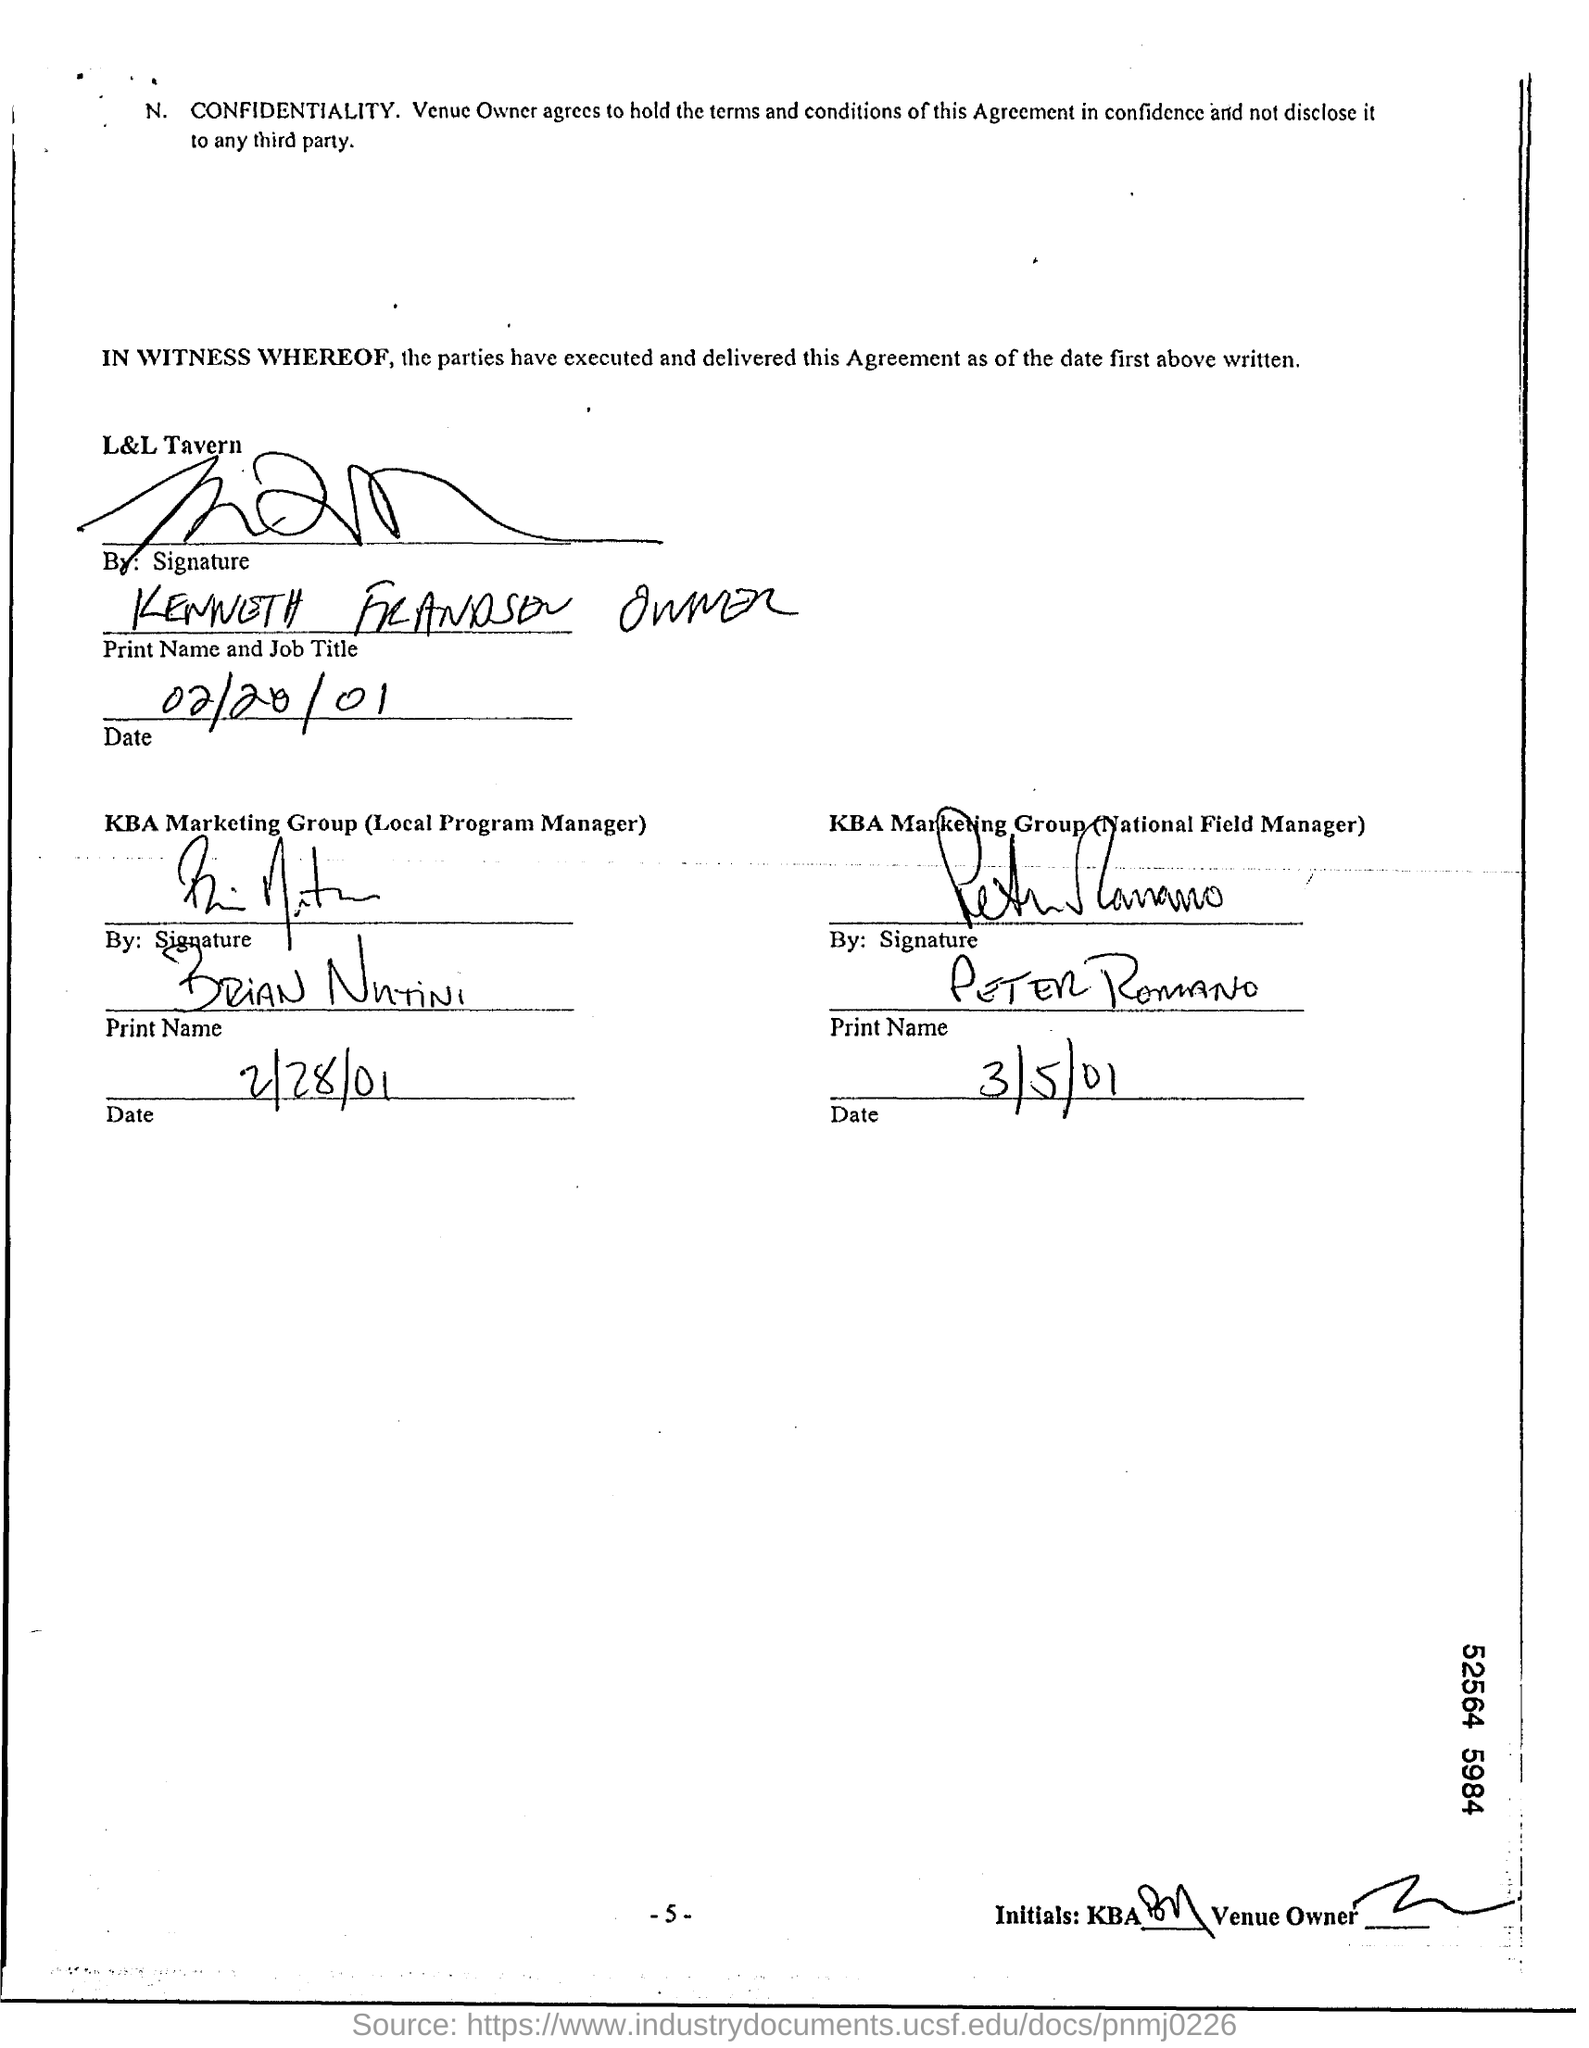What details can be noted about the National Field Manager's signature from KBA Marketing Group? The individual signing as the National Field Manager has a clear script with the name 'Peter Romano'. And the date next to this signature? The date next to Peter Romano's signature is '3/15/01'. 